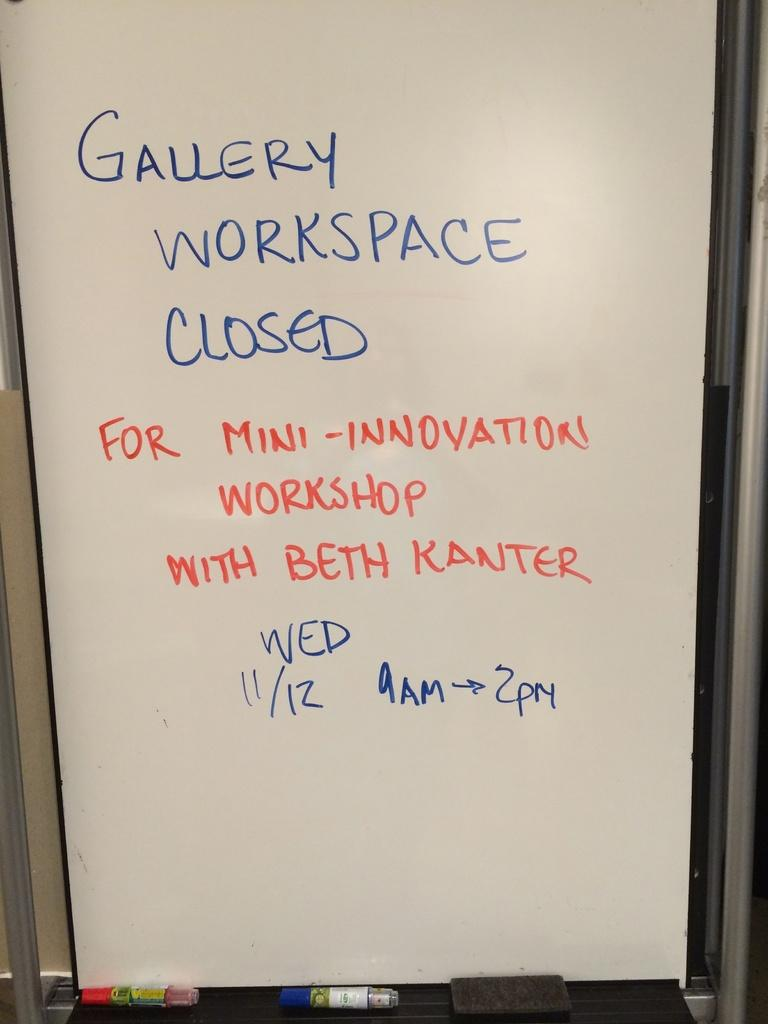Provide a one-sentence caption for the provided image. Gallery workspace closed written on a white board. 